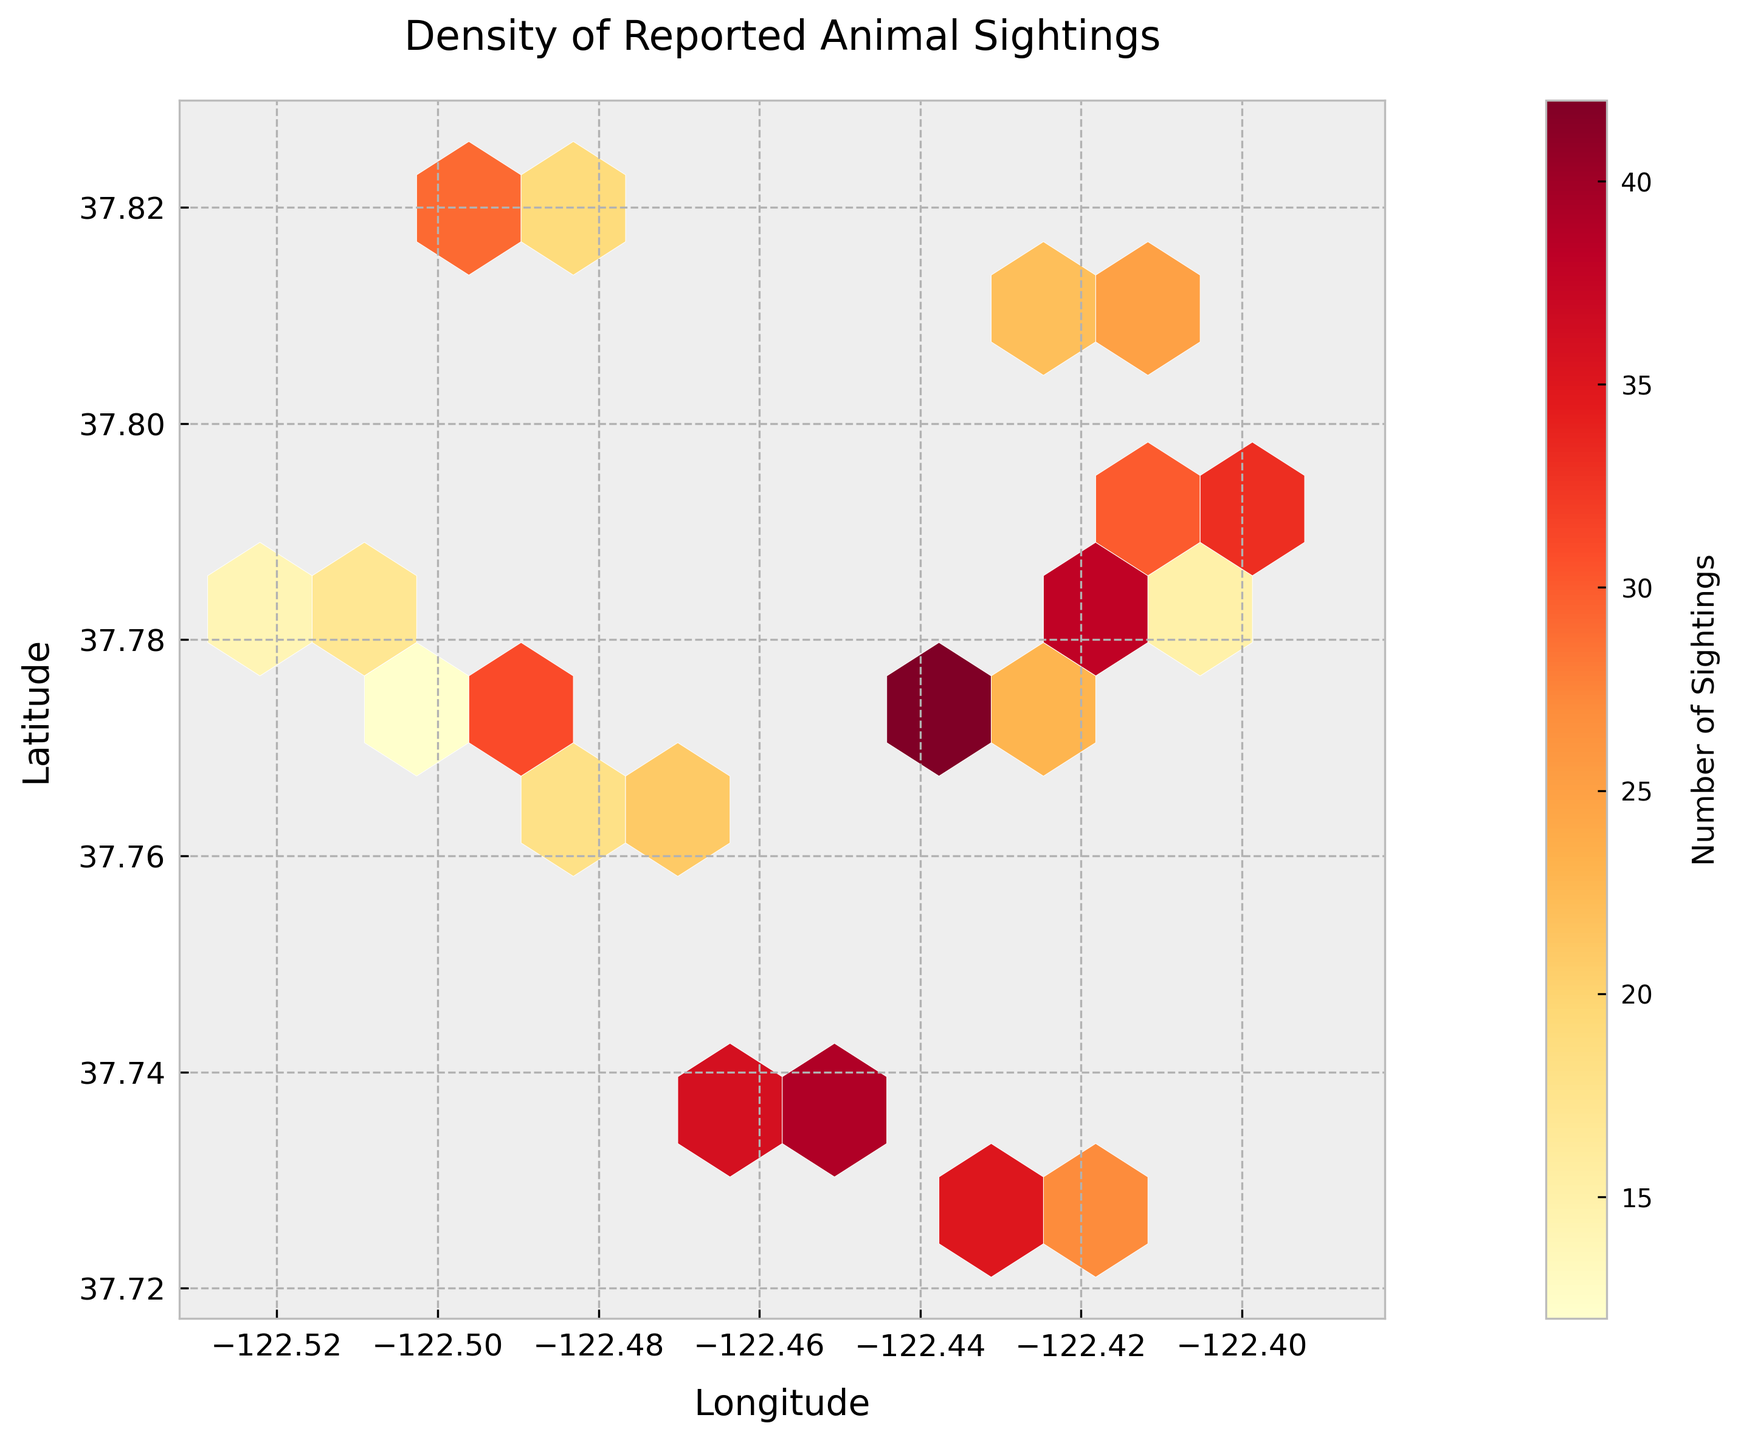what is the title of the plot? The title of the plot is clearly displayed at the top center of the figure. It reads "Density of Reported Animal Sightings".
Answer: Density of Reported Animal Sightings How does the color represent the number of sightings? In the hexbin plot, the color intensity of the hexagons represents the number of sightings. Darker reds indicate higher numbers of sightings, while lighter yellows indicate fewer sightings. The colormap "YlOrRd" (Yellow-Orange-Red) is used for this representation.
Answer: Darker red means more sightings, lighter yellow means fewer sightings What are the limits for latitude and longitude in the plot? The plot extends slightly beyond the minimum and maximum values of latitude and longitude to provide some padding. In this case, the range is from just below the minimum to just above the maximum of the latitude and longitude values in the data.
Answer: Latitude: around 37.72 to 37.82, Longitude: around -122.52 to -122.39 Which area has the highest density of sightings? By examining the plot, look for the hexagons colored in the darkest red, which indicates the highest density of sightings. From the data, the key area is around **latitude 37.7749, longitude -122.4330**.
Answer: Around latitude 37.7749, longitude -122.4330 Where is there a lower density of sightings compared to the area with the highest density? The hexagons in a lighter yellow color represent a lower density of sightings. You can compare these to the area with the highest density (dark red) to spot locations where sightings are fewer. For instance, around **latitude 37.7783, longitude -122.5221** which shows a much lighter shade.
Answer: Around latitude 37.7783, longitude -122.5221 What is the color bar on the right side of the plot, and what information does it provide? The color bar provides a scale for the number of sightings associated with each color in the hexbin plot. It ranges from the lightest yellow (fewest sightings) to the darkest red (most sightings). The label on the color bar reads "Number of Sightings", and it assists in interpreting the color density of the hexagons.
Answer: It shows the number of sightings corresponding to each color How does the density of sightings change as you move westward across the plot? Starting from the right side of the plot (eastern locations) and moving leftward (western locations), we see various changes in color density. Initially, there are moderate densities (lighter yellow to orange), but moving further west, we encounter areas of higher density (darker red around the center-west parts).
Answer: Density initially moderate, increases to high mid-west, and varies in other areas What insights can be drawn about animal sightings between the north-east and south-west corners of the plot? Comparing these areas involves looking at the colors of the hexagons in the north-east (top right) and south-west (bottom left). The north-east shows a mix of lower to moderate densities (yellow to light red). The south-west region, however, contains a mix of higher densities (darker oranges and reds).
Answer: South-west has higher densities, north-east has lower to moderate densities What is the range of the number of sightings in the color-bar legend, and how does it aid in understanding the hexbin plot's density? The color-bar legend ranges from light yellow to dark red, indicating the number of sightings from minimum to maximum within the plot. This legend helps viewers match the hexagon colors with the corresponding number of sightings, facilitating easier interpretation of the density distribution in the geographical coordinates.
Answer: Provides the range of sightings from minimum to maximum In what areas are the sighting densities approximately the same, and how can this be determined? Areas with similar shading or coloring (such as consistent shades of orange or red) indicate similar sighting densities. For example, examining two regions with similar shades, like **latitude 37.7749, longitude -122.4194** and **latitude 37.7858, longitude -122.4144**, suggest they have approximately the same density.
Answer: Near latitude 37.7749, longitude -122.4194 and latitude 37.7858, longitude -122.4144 